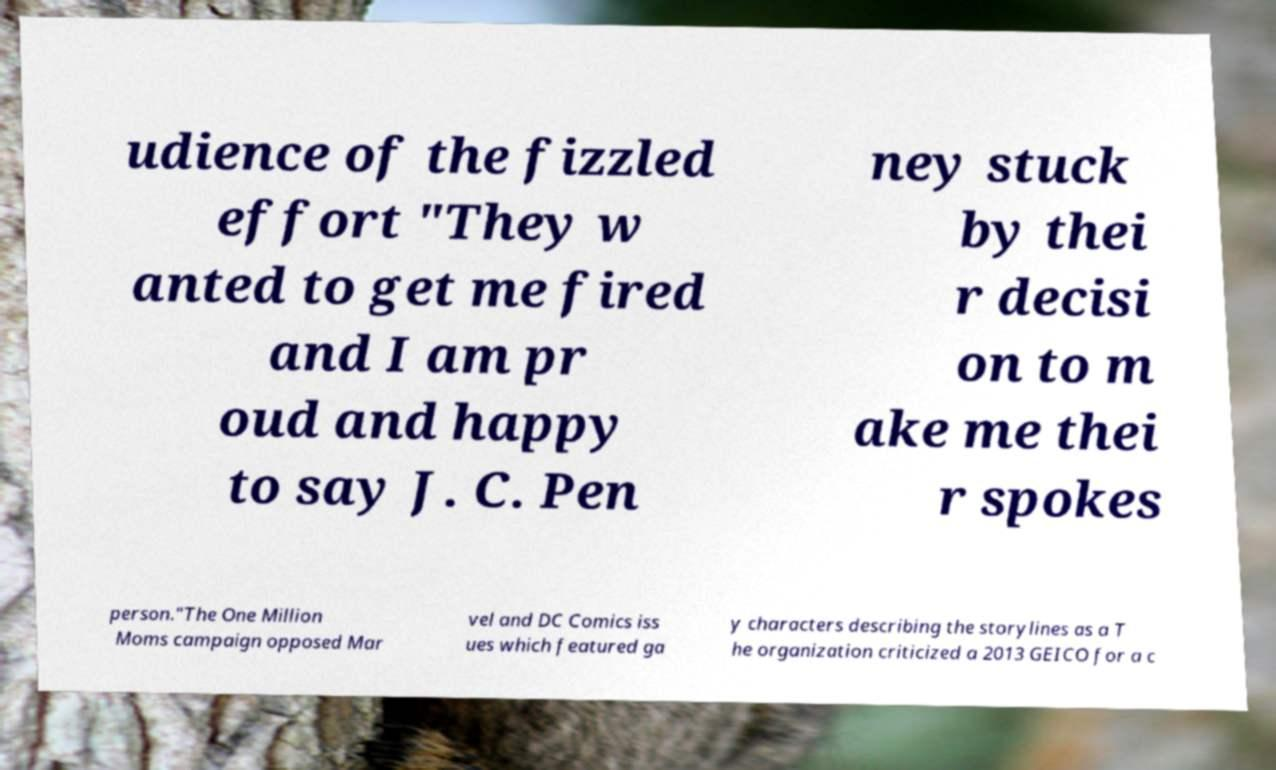Could you extract and type out the text from this image? udience of the fizzled effort "They w anted to get me fired and I am pr oud and happy to say J. C. Pen ney stuck by thei r decisi on to m ake me thei r spokes person."The One Million Moms campaign opposed Mar vel and DC Comics iss ues which featured ga y characters describing the storylines as a T he organization criticized a 2013 GEICO for a c 